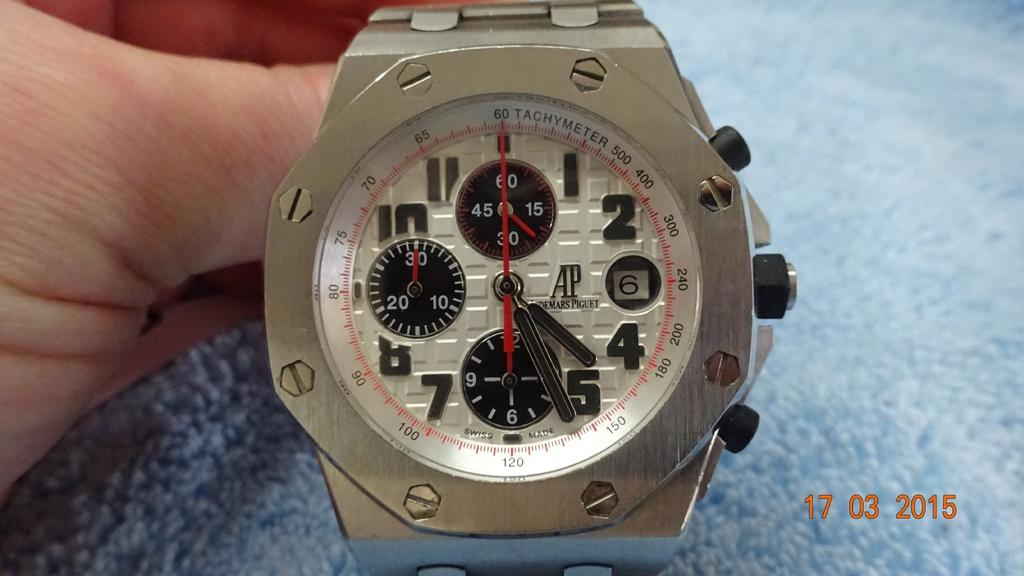<image>
Create a compact narrative representing the image presented. a watch face that is from a picture that says '17 03 2015' at the bottom right 